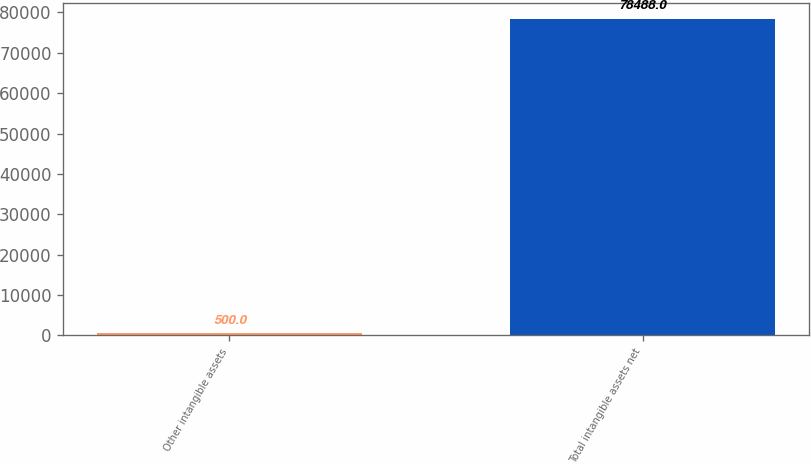Convert chart. <chart><loc_0><loc_0><loc_500><loc_500><bar_chart><fcel>Other intangible assets<fcel>Total intangible assets net<nl><fcel>500<fcel>78488<nl></chart> 